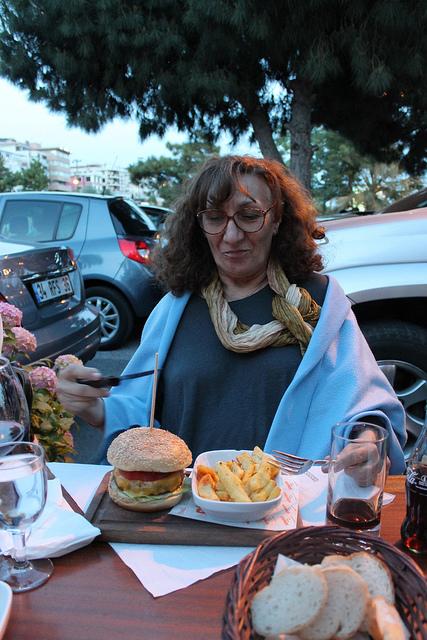Is the woman eating with fork and knife?
Concise answer only. Yes. Why are there cars parked behind her?
Concise answer only. Parking lot. Does the woman need a drink refill?
Quick response, please. Yes. 